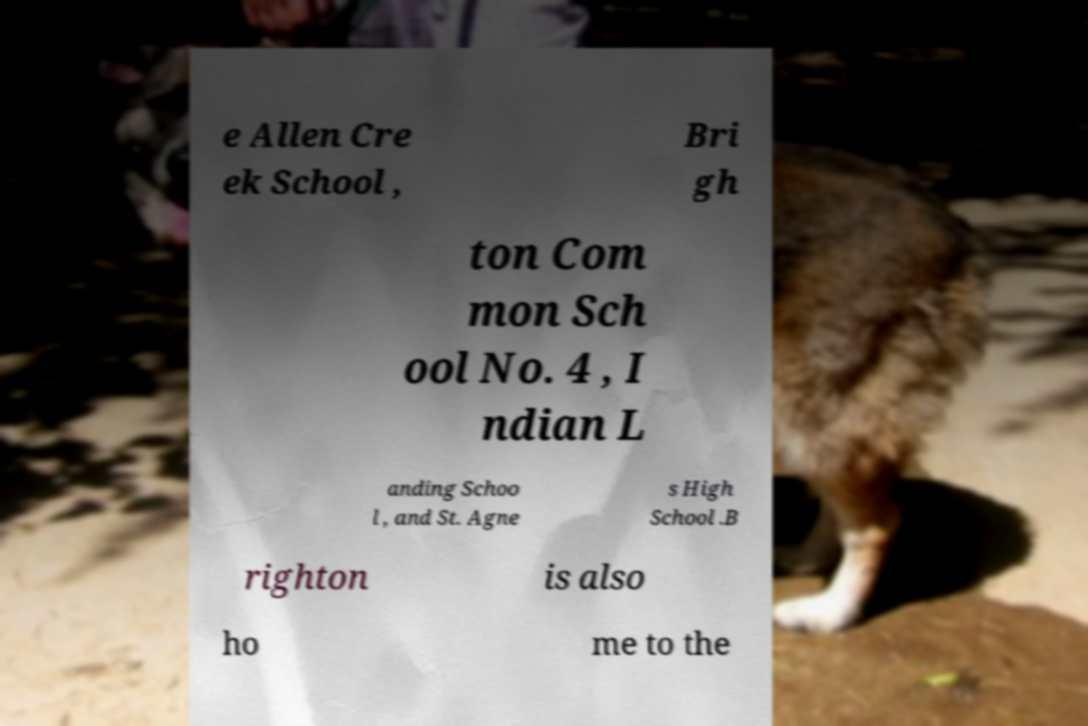I need the written content from this picture converted into text. Can you do that? e Allen Cre ek School , Bri gh ton Com mon Sch ool No. 4 , I ndian L anding Schoo l , and St. Agne s High School .B righton is also ho me to the 